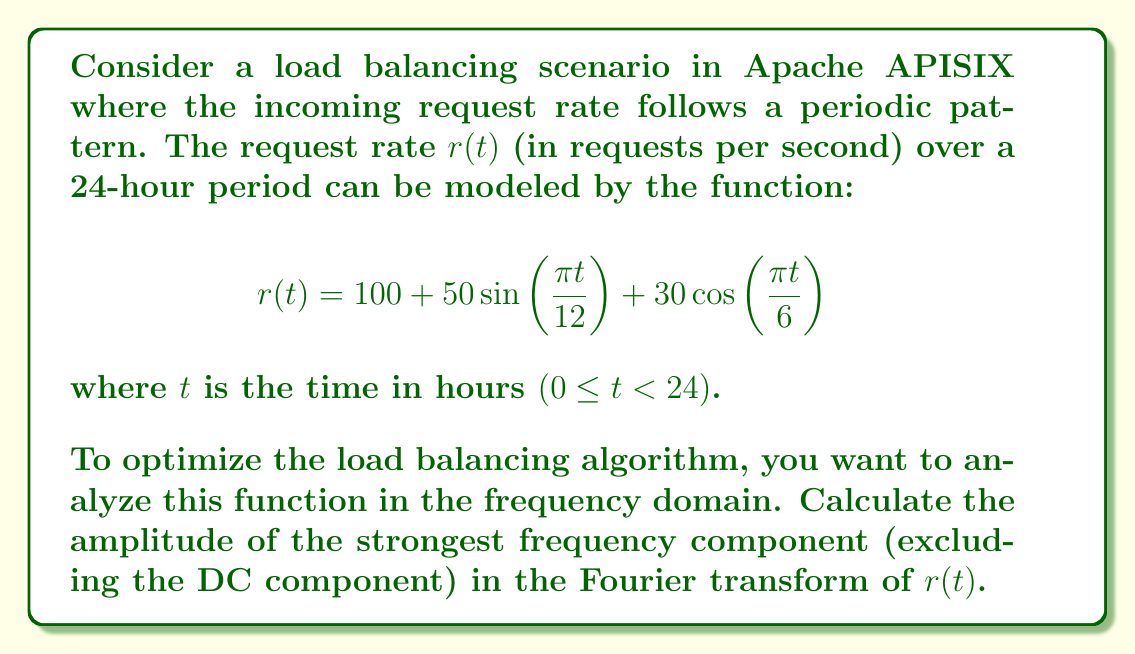Provide a solution to this math problem. To solve this problem, we'll follow these steps:

1) First, let's identify the frequencies present in the given function:
   
   $$r(t) = 100 + 50\sin\left(\frac{\pi t}{12}\right) + 30\cos\left(\frac{\pi t}{6}\right)$$

   The constant term 100 is the DC component.
   The sine term has a frequency of $\frac{\pi}{12}$ rad/hour or $\frac{1}{24}$ cycles/hour.
   The cosine term has a frequency of $\frac{\pi}{6}$ rad/hour or $\frac{1}{12}$ cycles/hour.

2) In the Fourier transform, these will appear as peaks at their respective frequencies.

3) The amplitude of each component in the time domain directly corresponds to its amplitude in the frequency domain for simple sinusoids.

4) The amplitudes of the frequency components are:
   - DC component: 100
   - $\frac{1}{24}$ cycles/hour component: 50
   - $\frac{1}{12}$ cycles/hour component: 30

5) Excluding the DC component, the strongest frequency component is the one with the largest amplitude.

6) Comparing 50 and 30, we see that 50 is larger.

Therefore, the amplitude of the strongest frequency component (excluding the DC component) is 50.
Answer: 50 